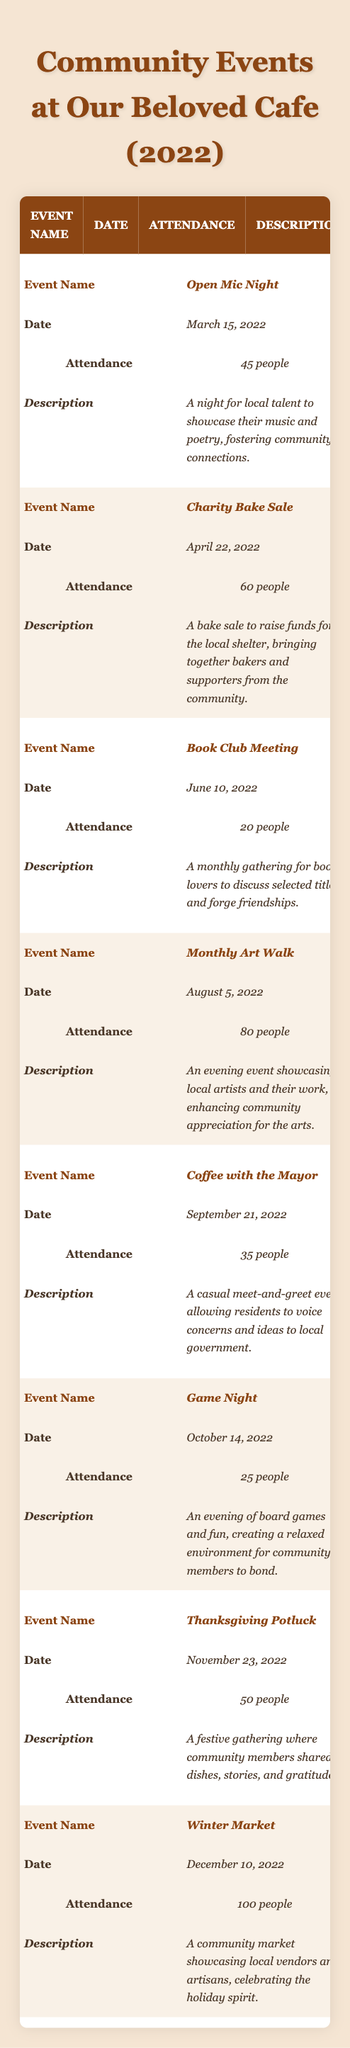What was the total attendance at all community events in 2022? To find the total attendance, we add up the attendance numbers for all events: 45 + 60 + 20 + 80 + 35 + 25 + 50 + 100 = 415
Answer: 415 Which event had the highest attendance? By reviewing the attendance for each event, the "Winter Market" had the highest attendance of 100 people.
Answer: Winter Market How many events were held in total? Counting the rows in the table, there are 8 events listed.
Answer: 8 What was the average attendance across all events? To find the average attendance, we divide the total attendance (415) by the number of events (8): 415 / 8 = 51.875, which we can round to 52.
Answer: 52 Did the "Charity Bake Sale" have more attendees than the "Game Night"? Comparing the attendance, the "Charity Bake Sale" had 60 attendees, while "Game Night" had 25, so yes, it had more attendees.
Answer: Yes What is the date of the "Thanksgiving Potluck"? The date listed for the "Thanksgiving Potluck" is November 23, 2022.
Answer: November 23, 2022 Which event took place in March? From the table, the event that took place in March is the "Open Mic Night" on March 15, 2022.
Answer: Open Mic Night How many events had an attendance of less than 30 people? By checking the attendance numbers, only the "Game Night" had fewer than 30 attendees, with 25 people attending.
Answer: 1 What was the main purpose of the "Coffee with the Mayor" event? The description states that it was a casual meet-and-greet event for residents to voice concerns and ideas to local government.
Answer: To voice concerns to local government Which month had the most events hosted at the cafe? We check the dates; there was one event per month except for December with just one event, making all other months equal with one event each. Thus, they are all tied.
Answer: All months are equal 